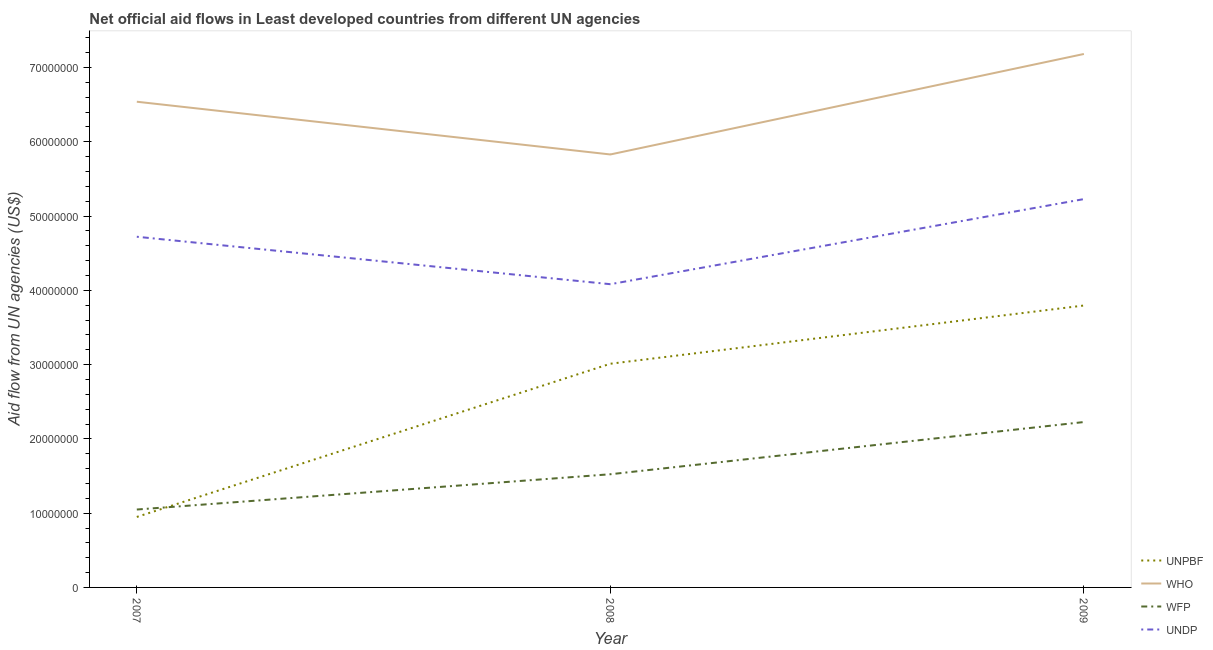How many different coloured lines are there?
Your response must be concise. 4. Is the number of lines equal to the number of legend labels?
Ensure brevity in your answer.  Yes. What is the amount of aid given by who in 2008?
Offer a very short reply. 5.83e+07. Across all years, what is the maximum amount of aid given by wfp?
Your answer should be compact. 2.23e+07. Across all years, what is the minimum amount of aid given by unpbf?
Your answer should be compact. 9.49e+06. In which year was the amount of aid given by unpbf minimum?
Make the answer very short. 2007. What is the total amount of aid given by unpbf in the graph?
Offer a terse response. 7.76e+07. What is the difference between the amount of aid given by wfp in 2008 and that in 2009?
Your answer should be compact. -7.03e+06. What is the difference between the amount of aid given by unpbf in 2007 and the amount of aid given by undp in 2008?
Your answer should be very brief. -3.13e+07. What is the average amount of aid given by unpbf per year?
Offer a very short reply. 2.59e+07. In the year 2009, what is the difference between the amount of aid given by who and amount of aid given by wfp?
Your answer should be compact. 4.96e+07. In how many years, is the amount of aid given by who greater than 52000000 US$?
Ensure brevity in your answer.  3. What is the ratio of the amount of aid given by undp in 2007 to that in 2008?
Ensure brevity in your answer.  1.16. What is the difference between the highest and the second highest amount of aid given by who?
Make the answer very short. 6.43e+06. What is the difference between the highest and the lowest amount of aid given by undp?
Make the answer very short. 1.15e+07. In how many years, is the amount of aid given by wfp greater than the average amount of aid given by wfp taken over all years?
Your answer should be compact. 1. Is the sum of the amount of aid given by undp in 2008 and 2009 greater than the maximum amount of aid given by wfp across all years?
Make the answer very short. Yes. Is it the case that in every year, the sum of the amount of aid given by unpbf and amount of aid given by undp is greater than the sum of amount of aid given by wfp and amount of aid given by who?
Offer a terse response. Yes. Is it the case that in every year, the sum of the amount of aid given by unpbf and amount of aid given by who is greater than the amount of aid given by wfp?
Offer a very short reply. Yes. Is the amount of aid given by wfp strictly less than the amount of aid given by unpbf over the years?
Make the answer very short. No. How many years are there in the graph?
Give a very brief answer. 3. Are the values on the major ticks of Y-axis written in scientific E-notation?
Offer a terse response. No. Does the graph contain any zero values?
Provide a succinct answer. No. Where does the legend appear in the graph?
Provide a succinct answer. Bottom right. How many legend labels are there?
Make the answer very short. 4. How are the legend labels stacked?
Your answer should be compact. Vertical. What is the title of the graph?
Your answer should be compact. Net official aid flows in Least developed countries from different UN agencies. What is the label or title of the Y-axis?
Give a very brief answer. Aid flow from UN agencies (US$). What is the Aid flow from UN agencies (US$) in UNPBF in 2007?
Ensure brevity in your answer.  9.49e+06. What is the Aid flow from UN agencies (US$) of WHO in 2007?
Offer a very short reply. 6.54e+07. What is the Aid flow from UN agencies (US$) of WFP in 2007?
Keep it short and to the point. 1.05e+07. What is the Aid flow from UN agencies (US$) in UNDP in 2007?
Provide a succinct answer. 4.72e+07. What is the Aid flow from UN agencies (US$) in UNPBF in 2008?
Provide a short and direct response. 3.01e+07. What is the Aid flow from UN agencies (US$) of WHO in 2008?
Provide a succinct answer. 5.83e+07. What is the Aid flow from UN agencies (US$) in WFP in 2008?
Make the answer very short. 1.52e+07. What is the Aid flow from UN agencies (US$) in UNDP in 2008?
Your response must be concise. 4.08e+07. What is the Aid flow from UN agencies (US$) in UNPBF in 2009?
Ensure brevity in your answer.  3.80e+07. What is the Aid flow from UN agencies (US$) of WHO in 2009?
Offer a very short reply. 7.18e+07. What is the Aid flow from UN agencies (US$) in WFP in 2009?
Your answer should be very brief. 2.23e+07. What is the Aid flow from UN agencies (US$) of UNDP in 2009?
Keep it short and to the point. 5.23e+07. Across all years, what is the maximum Aid flow from UN agencies (US$) in UNPBF?
Offer a terse response. 3.80e+07. Across all years, what is the maximum Aid flow from UN agencies (US$) in WHO?
Provide a short and direct response. 7.18e+07. Across all years, what is the maximum Aid flow from UN agencies (US$) in WFP?
Your answer should be very brief. 2.23e+07. Across all years, what is the maximum Aid flow from UN agencies (US$) in UNDP?
Provide a short and direct response. 5.23e+07. Across all years, what is the minimum Aid flow from UN agencies (US$) of UNPBF?
Make the answer very short. 9.49e+06. Across all years, what is the minimum Aid flow from UN agencies (US$) in WHO?
Your answer should be compact. 5.83e+07. Across all years, what is the minimum Aid flow from UN agencies (US$) of WFP?
Your answer should be very brief. 1.05e+07. Across all years, what is the minimum Aid flow from UN agencies (US$) of UNDP?
Offer a terse response. 4.08e+07. What is the total Aid flow from UN agencies (US$) in UNPBF in the graph?
Ensure brevity in your answer.  7.76e+07. What is the total Aid flow from UN agencies (US$) in WHO in the graph?
Ensure brevity in your answer.  1.96e+08. What is the total Aid flow from UN agencies (US$) in WFP in the graph?
Offer a terse response. 4.80e+07. What is the total Aid flow from UN agencies (US$) of UNDP in the graph?
Keep it short and to the point. 1.40e+08. What is the difference between the Aid flow from UN agencies (US$) in UNPBF in 2007 and that in 2008?
Your answer should be very brief. -2.06e+07. What is the difference between the Aid flow from UN agencies (US$) of WHO in 2007 and that in 2008?
Your response must be concise. 7.10e+06. What is the difference between the Aid flow from UN agencies (US$) of WFP in 2007 and that in 2008?
Give a very brief answer. -4.75e+06. What is the difference between the Aid flow from UN agencies (US$) in UNDP in 2007 and that in 2008?
Offer a very short reply. 6.39e+06. What is the difference between the Aid flow from UN agencies (US$) in UNPBF in 2007 and that in 2009?
Provide a succinct answer. -2.85e+07. What is the difference between the Aid flow from UN agencies (US$) of WHO in 2007 and that in 2009?
Provide a succinct answer. -6.43e+06. What is the difference between the Aid flow from UN agencies (US$) of WFP in 2007 and that in 2009?
Provide a short and direct response. -1.18e+07. What is the difference between the Aid flow from UN agencies (US$) in UNDP in 2007 and that in 2009?
Your answer should be very brief. -5.07e+06. What is the difference between the Aid flow from UN agencies (US$) of UNPBF in 2008 and that in 2009?
Make the answer very short. -7.84e+06. What is the difference between the Aid flow from UN agencies (US$) of WHO in 2008 and that in 2009?
Provide a short and direct response. -1.35e+07. What is the difference between the Aid flow from UN agencies (US$) of WFP in 2008 and that in 2009?
Provide a succinct answer. -7.03e+06. What is the difference between the Aid flow from UN agencies (US$) in UNDP in 2008 and that in 2009?
Ensure brevity in your answer.  -1.15e+07. What is the difference between the Aid flow from UN agencies (US$) in UNPBF in 2007 and the Aid flow from UN agencies (US$) in WHO in 2008?
Ensure brevity in your answer.  -4.88e+07. What is the difference between the Aid flow from UN agencies (US$) in UNPBF in 2007 and the Aid flow from UN agencies (US$) in WFP in 2008?
Your answer should be compact. -5.75e+06. What is the difference between the Aid flow from UN agencies (US$) in UNPBF in 2007 and the Aid flow from UN agencies (US$) in UNDP in 2008?
Your answer should be very brief. -3.13e+07. What is the difference between the Aid flow from UN agencies (US$) in WHO in 2007 and the Aid flow from UN agencies (US$) in WFP in 2008?
Offer a very short reply. 5.02e+07. What is the difference between the Aid flow from UN agencies (US$) of WHO in 2007 and the Aid flow from UN agencies (US$) of UNDP in 2008?
Provide a succinct answer. 2.46e+07. What is the difference between the Aid flow from UN agencies (US$) of WFP in 2007 and the Aid flow from UN agencies (US$) of UNDP in 2008?
Offer a terse response. -3.03e+07. What is the difference between the Aid flow from UN agencies (US$) in UNPBF in 2007 and the Aid flow from UN agencies (US$) in WHO in 2009?
Offer a very short reply. -6.23e+07. What is the difference between the Aid flow from UN agencies (US$) in UNPBF in 2007 and the Aid flow from UN agencies (US$) in WFP in 2009?
Offer a very short reply. -1.28e+07. What is the difference between the Aid flow from UN agencies (US$) of UNPBF in 2007 and the Aid flow from UN agencies (US$) of UNDP in 2009?
Offer a terse response. -4.28e+07. What is the difference between the Aid flow from UN agencies (US$) in WHO in 2007 and the Aid flow from UN agencies (US$) in WFP in 2009?
Offer a terse response. 4.31e+07. What is the difference between the Aid flow from UN agencies (US$) in WHO in 2007 and the Aid flow from UN agencies (US$) in UNDP in 2009?
Offer a very short reply. 1.31e+07. What is the difference between the Aid flow from UN agencies (US$) in WFP in 2007 and the Aid flow from UN agencies (US$) in UNDP in 2009?
Give a very brief answer. -4.18e+07. What is the difference between the Aid flow from UN agencies (US$) in UNPBF in 2008 and the Aid flow from UN agencies (US$) in WHO in 2009?
Your answer should be compact. -4.17e+07. What is the difference between the Aid flow from UN agencies (US$) in UNPBF in 2008 and the Aid flow from UN agencies (US$) in WFP in 2009?
Keep it short and to the point. 7.85e+06. What is the difference between the Aid flow from UN agencies (US$) in UNPBF in 2008 and the Aid flow from UN agencies (US$) in UNDP in 2009?
Give a very brief answer. -2.22e+07. What is the difference between the Aid flow from UN agencies (US$) in WHO in 2008 and the Aid flow from UN agencies (US$) in WFP in 2009?
Your answer should be compact. 3.60e+07. What is the difference between the Aid flow from UN agencies (US$) in WHO in 2008 and the Aid flow from UN agencies (US$) in UNDP in 2009?
Your answer should be very brief. 6.01e+06. What is the difference between the Aid flow from UN agencies (US$) of WFP in 2008 and the Aid flow from UN agencies (US$) of UNDP in 2009?
Your answer should be compact. -3.70e+07. What is the average Aid flow from UN agencies (US$) of UNPBF per year?
Make the answer very short. 2.59e+07. What is the average Aid flow from UN agencies (US$) in WHO per year?
Offer a very short reply. 6.52e+07. What is the average Aid flow from UN agencies (US$) of WFP per year?
Your answer should be compact. 1.60e+07. What is the average Aid flow from UN agencies (US$) of UNDP per year?
Your response must be concise. 4.68e+07. In the year 2007, what is the difference between the Aid flow from UN agencies (US$) of UNPBF and Aid flow from UN agencies (US$) of WHO?
Provide a short and direct response. -5.59e+07. In the year 2007, what is the difference between the Aid flow from UN agencies (US$) of UNPBF and Aid flow from UN agencies (US$) of UNDP?
Keep it short and to the point. -3.77e+07. In the year 2007, what is the difference between the Aid flow from UN agencies (US$) of WHO and Aid flow from UN agencies (US$) of WFP?
Give a very brief answer. 5.49e+07. In the year 2007, what is the difference between the Aid flow from UN agencies (US$) of WHO and Aid flow from UN agencies (US$) of UNDP?
Offer a terse response. 1.82e+07. In the year 2007, what is the difference between the Aid flow from UN agencies (US$) in WFP and Aid flow from UN agencies (US$) in UNDP?
Your answer should be compact. -3.67e+07. In the year 2008, what is the difference between the Aid flow from UN agencies (US$) in UNPBF and Aid flow from UN agencies (US$) in WHO?
Ensure brevity in your answer.  -2.82e+07. In the year 2008, what is the difference between the Aid flow from UN agencies (US$) in UNPBF and Aid flow from UN agencies (US$) in WFP?
Ensure brevity in your answer.  1.49e+07. In the year 2008, what is the difference between the Aid flow from UN agencies (US$) in UNPBF and Aid flow from UN agencies (US$) in UNDP?
Offer a very short reply. -1.07e+07. In the year 2008, what is the difference between the Aid flow from UN agencies (US$) of WHO and Aid flow from UN agencies (US$) of WFP?
Your answer should be very brief. 4.31e+07. In the year 2008, what is the difference between the Aid flow from UN agencies (US$) in WHO and Aid flow from UN agencies (US$) in UNDP?
Make the answer very short. 1.75e+07. In the year 2008, what is the difference between the Aid flow from UN agencies (US$) in WFP and Aid flow from UN agencies (US$) in UNDP?
Keep it short and to the point. -2.56e+07. In the year 2009, what is the difference between the Aid flow from UN agencies (US$) in UNPBF and Aid flow from UN agencies (US$) in WHO?
Make the answer very short. -3.39e+07. In the year 2009, what is the difference between the Aid flow from UN agencies (US$) of UNPBF and Aid flow from UN agencies (US$) of WFP?
Ensure brevity in your answer.  1.57e+07. In the year 2009, what is the difference between the Aid flow from UN agencies (US$) in UNPBF and Aid flow from UN agencies (US$) in UNDP?
Your answer should be compact. -1.43e+07. In the year 2009, what is the difference between the Aid flow from UN agencies (US$) of WHO and Aid flow from UN agencies (US$) of WFP?
Your answer should be very brief. 4.96e+07. In the year 2009, what is the difference between the Aid flow from UN agencies (US$) in WHO and Aid flow from UN agencies (US$) in UNDP?
Keep it short and to the point. 1.95e+07. In the year 2009, what is the difference between the Aid flow from UN agencies (US$) in WFP and Aid flow from UN agencies (US$) in UNDP?
Provide a short and direct response. -3.00e+07. What is the ratio of the Aid flow from UN agencies (US$) of UNPBF in 2007 to that in 2008?
Offer a terse response. 0.32. What is the ratio of the Aid flow from UN agencies (US$) of WHO in 2007 to that in 2008?
Keep it short and to the point. 1.12. What is the ratio of the Aid flow from UN agencies (US$) of WFP in 2007 to that in 2008?
Give a very brief answer. 0.69. What is the ratio of the Aid flow from UN agencies (US$) in UNDP in 2007 to that in 2008?
Your answer should be compact. 1.16. What is the ratio of the Aid flow from UN agencies (US$) in WHO in 2007 to that in 2009?
Provide a short and direct response. 0.91. What is the ratio of the Aid flow from UN agencies (US$) in WFP in 2007 to that in 2009?
Your answer should be very brief. 0.47. What is the ratio of the Aid flow from UN agencies (US$) in UNDP in 2007 to that in 2009?
Offer a very short reply. 0.9. What is the ratio of the Aid flow from UN agencies (US$) in UNPBF in 2008 to that in 2009?
Give a very brief answer. 0.79. What is the ratio of the Aid flow from UN agencies (US$) of WHO in 2008 to that in 2009?
Offer a very short reply. 0.81. What is the ratio of the Aid flow from UN agencies (US$) in WFP in 2008 to that in 2009?
Your answer should be very brief. 0.68. What is the ratio of the Aid flow from UN agencies (US$) in UNDP in 2008 to that in 2009?
Make the answer very short. 0.78. What is the difference between the highest and the second highest Aid flow from UN agencies (US$) in UNPBF?
Make the answer very short. 7.84e+06. What is the difference between the highest and the second highest Aid flow from UN agencies (US$) in WHO?
Provide a short and direct response. 6.43e+06. What is the difference between the highest and the second highest Aid flow from UN agencies (US$) in WFP?
Give a very brief answer. 7.03e+06. What is the difference between the highest and the second highest Aid flow from UN agencies (US$) of UNDP?
Provide a short and direct response. 5.07e+06. What is the difference between the highest and the lowest Aid flow from UN agencies (US$) in UNPBF?
Your response must be concise. 2.85e+07. What is the difference between the highest and the lowest Aid flow from UN agencies (US$) in WHO?
Keep it short and to the point. 1.35e+07. What is the difference between the highest and the lowest Aid flow from UN agencies (US$) in WFP?
Your response must be concise. 1.18e+07. What is the difference between the highest and the lowest Aid flow from UN agencies (US$) in UNDP?
Your answer should be very brief. 1.15e+07. 